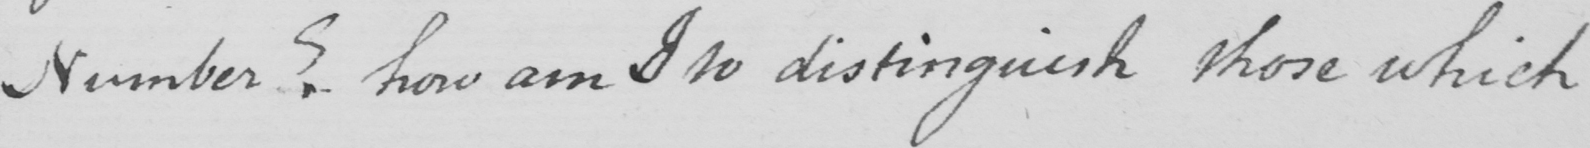What does this handwritten line say? Number ?  how am I to distinguish those which 